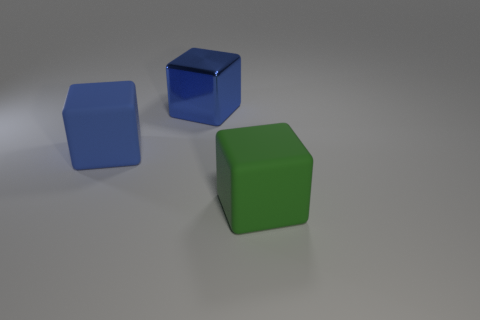Subtract all big blue matte cubes. How many cubes are left? 2 Add 3 tiny yellow matte things. How many objects exist? 6 Subtract all green cubes. How many cubes are left? 2 Subtract 1 blocks. How many blocks are left? 2 Subtract all big cubes. Subtract all tiny blue spheres. How many objects are left? 0 Add 3 big cubes. How many big cubes are left? 6 Add 1 tiny gray metal objects. How many tiny gray metal objects exist? 1 Subtract 0 blue balls. How many objects are left? 3 Subtract all purple cubes. Subtract all red cylinders. How many cubes are left? 3 Subtract all blue cylinders. How many gray blocks are left? 0 